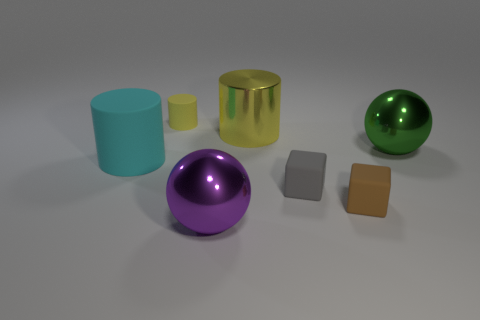Add 2 tiny gray matte balls. How many objects exist? 9 Subtract all spheres. How many objects are left? 5 Subtract all large cyan cylinders. Subtract all yellow shiny objects. How many objects are left? 5 Add 7 big purple shiny balls. How many big purple shiny balls are left? 8 Add 5 purple metal cylinders. How many purple metal cylinders exist? 5 Subtract 0 gray balls. How many objects are left? 7 